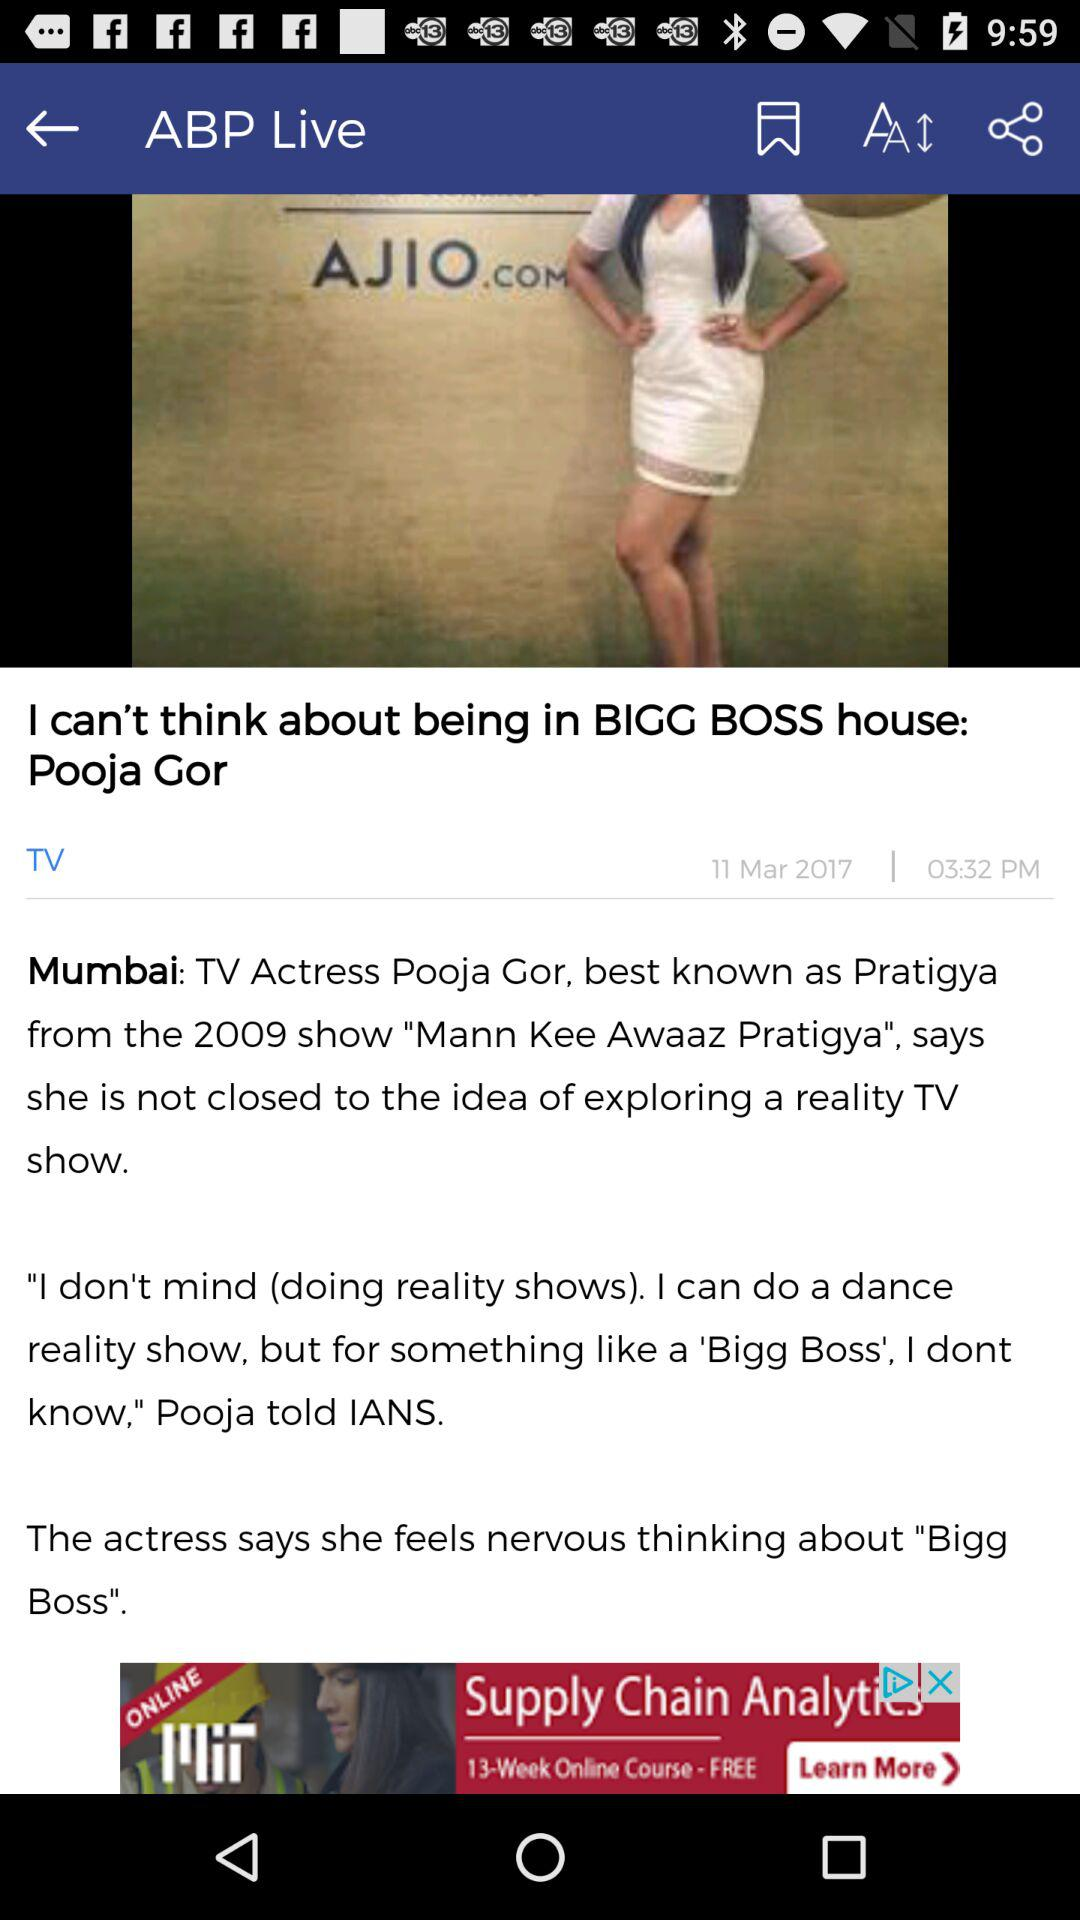Which television show is the article form?
When the provided information is insufficient, respond with <no answer>. <no answer> 